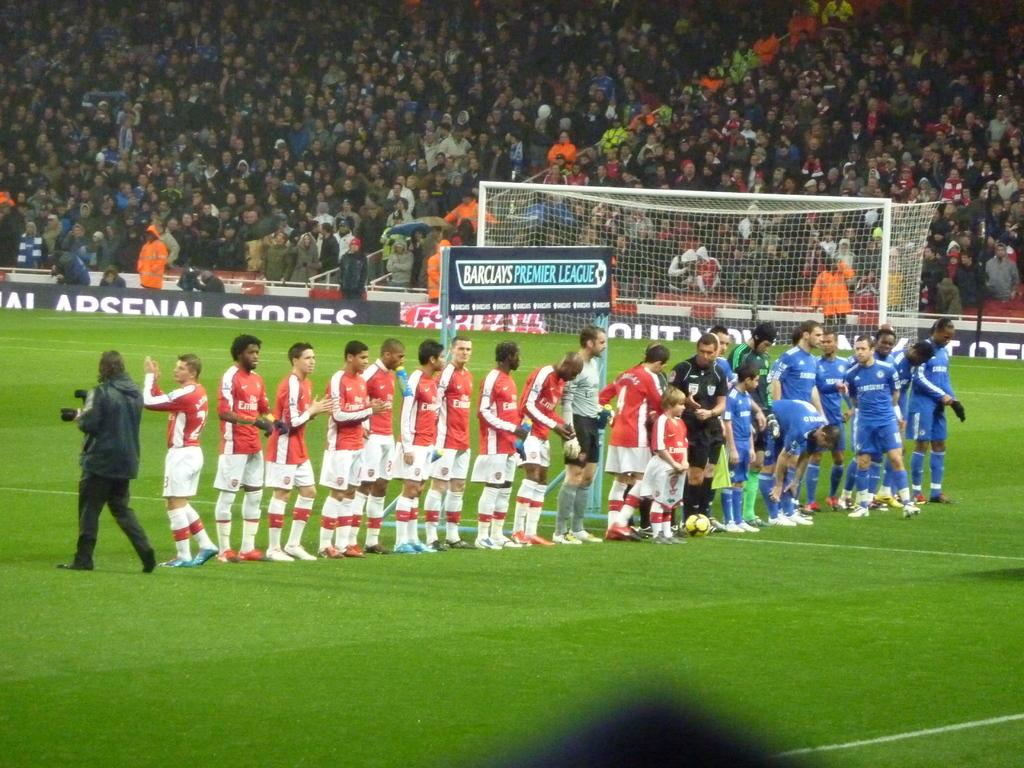Provide a one-sentence caption for the provided image. Athletes on a field in front of a sign that says Barclay's Premier League. 